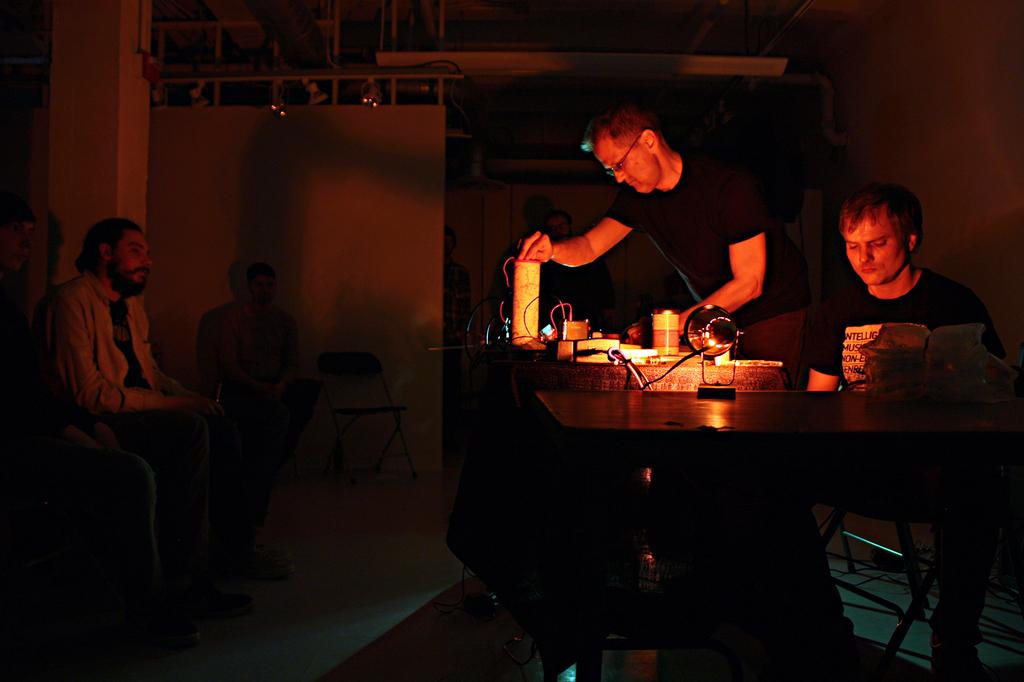How many people are in the image? There is a group of people in the image. What are some of the people in the image doing? Some people are sitting on chairs. What is the position of the person in front of the table? There is a person standing in front of a table. What can be found on the table? There are objects on the table. What invention is being demonstrated by the giants in the image? There are no giants present in the image, and therefore no invention can be demonstrated. 